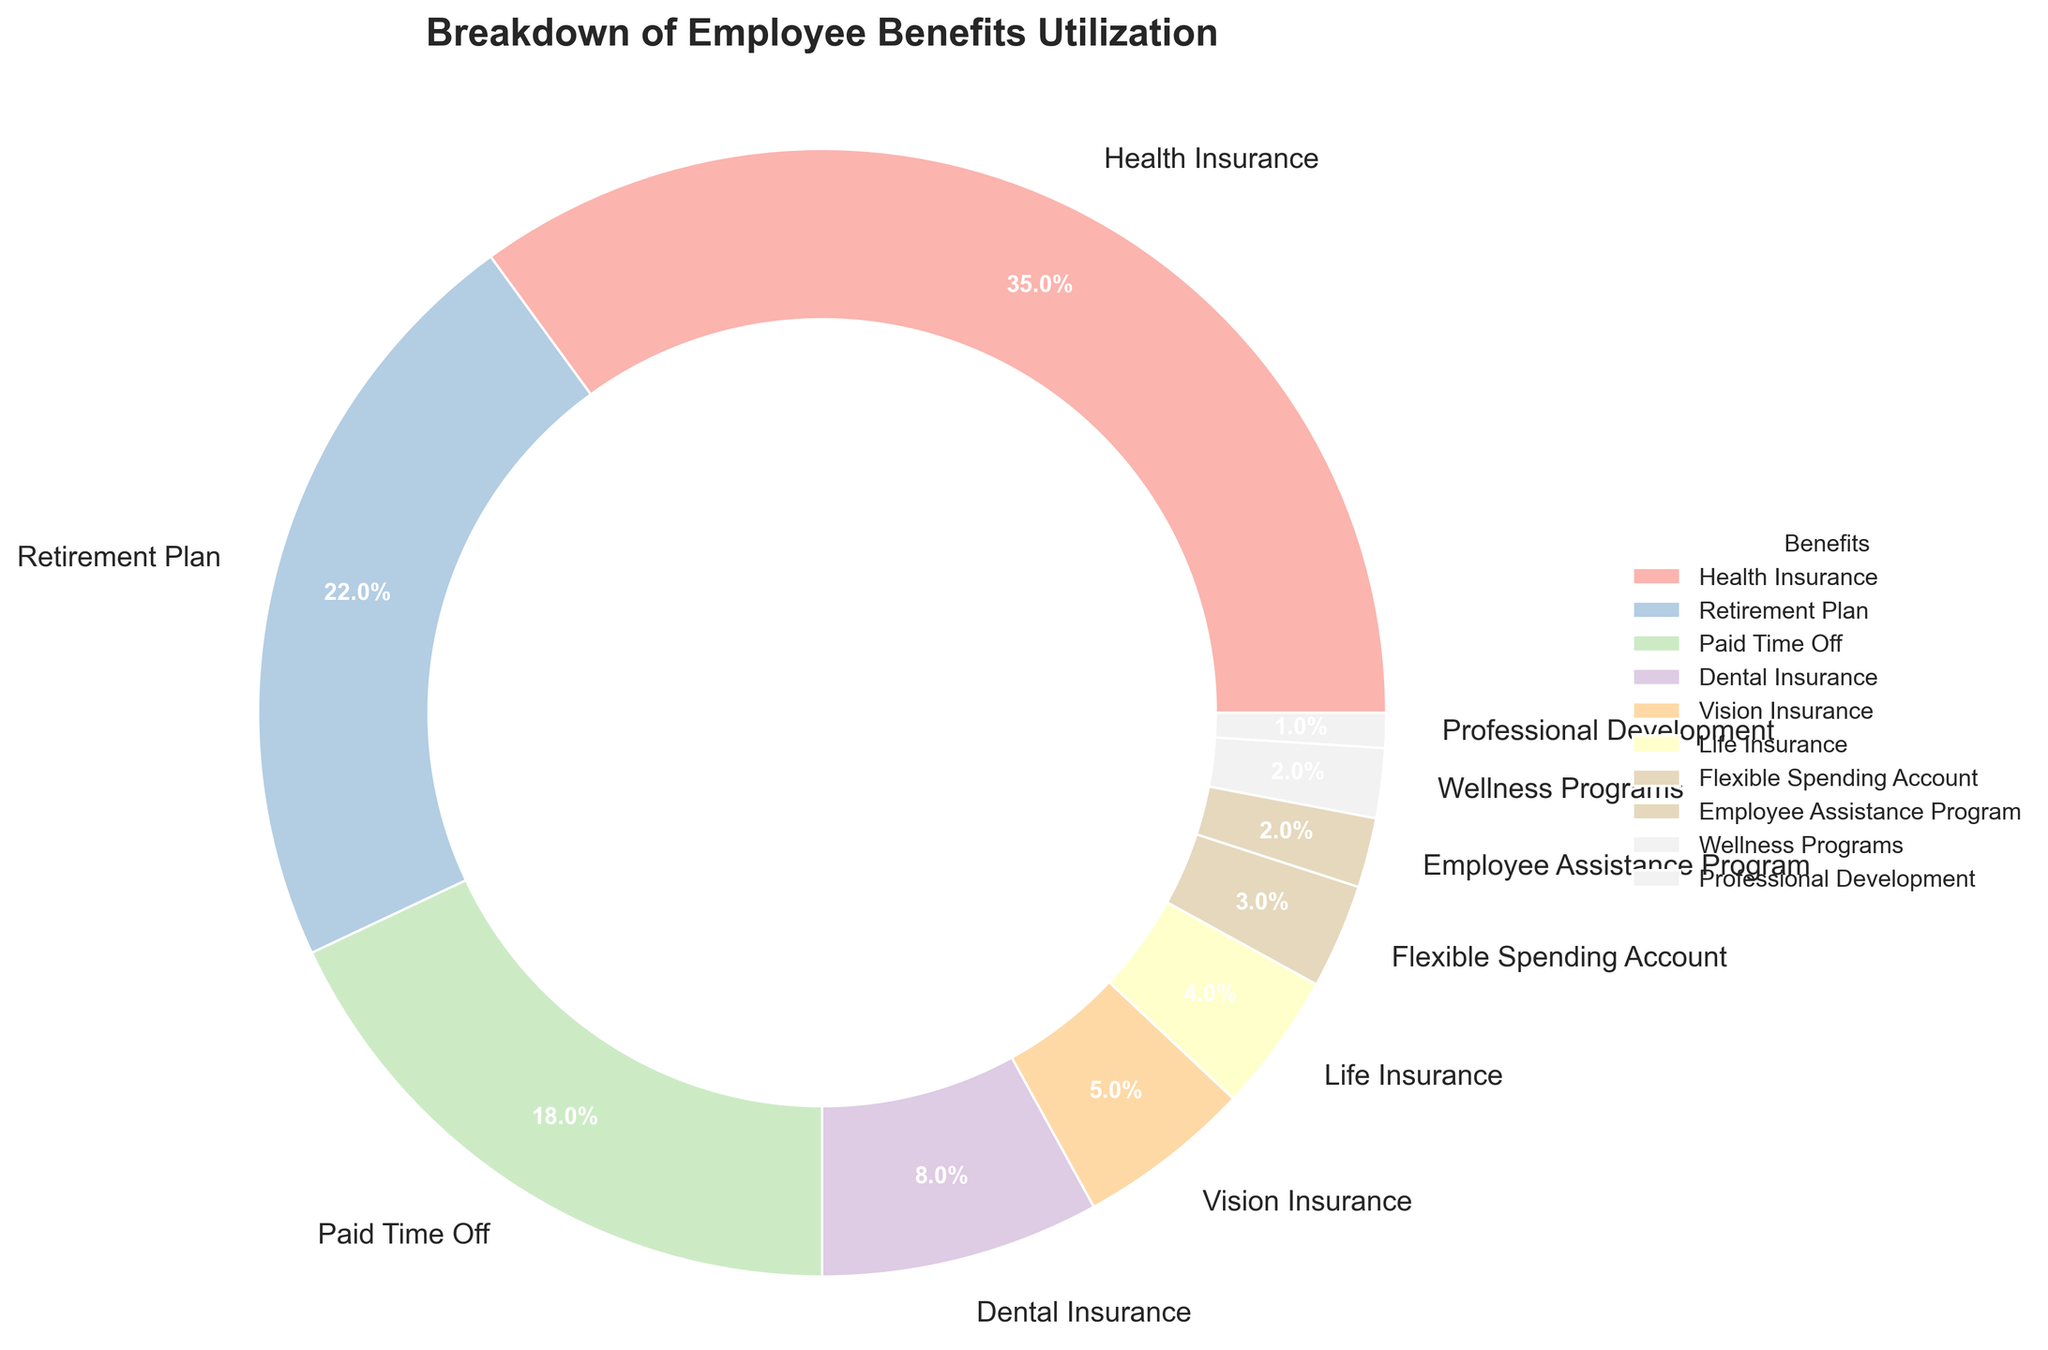Which benefit has the highest utilization percentage? Visually, the largest section of the pie chart is labeled "Health Insurance," showing it has the largest proportion.
Answer: Health Insurance What is the combined percentage of Health Insurance and Retirement Plan utilization? The percentages for Health Insurance and Retirement Plan are 35% and 22%, respectively. Summing them up gives 35% + 22% = 57%.
Answer: 57% How much more utilized is Health Insurance compared to Paid Time Off? The utilization percentage for Health Insurance is 35%, and for Paid Time Off, it is 18%. The difference is 35% - 18% = 17%.
Answer: 17% Which benefit has the lowest utilization percentage? The smallest segment in the pie chart is labeled "Professional Development," indicating it has the lowest proportion.
Answer: Professional Development Rank the top three benefits by utilization. By inspecting the size of the segments in the pie chart, we can see that the top three benefits by utilization are: 1) Health Insurance (35%), 2) Retirement Plan (22%), 3) Paid Time Off (18%).
Answer: Health Insurance, Retirement Plan, Paid Time Off Are Dental Insurance and Vision Insurance utilization percentages combined greater than that of Paid Time Off? The percentages for Dental Insurance and Vision Insurance are 8% and 5%, respectively. Combined, they are 8% + 5% = 13%. The percentage for Paid Time Off is 18%, which is greater.
Answer: No Is the utilization of Life Insurance more than twice the utilization of the Employee Assistance Program? The percentage for Life Insurance is 4%, and for the Employee Assistance Program, it is 2%. Since 4% is exactly twice 2%, Life Insurance is not more than twice as much.
Answer: No What is the difference in utilization percentages between Vision Insurance and the Flexible Spending Account? Vision Insurance has a utilization percentage of 5%, and the Flexible Spending Account has 3%. The difference is 5% - 3% = 2%.
Answer: 2% Is the total percentage of benefits with less than 5% utilization greater than or equal to 10%? Adding up the percentages for Vision Insurance (5%), Life Insurance (4%), Flexible Spending Account (3%), Employee Assistance Program (2%), Wellness Programs (2%), and Professional Development (1%) gives 5% + 4% + 3% + 2% + 2% + 1% = 17%, which is greater than 10%.
Answer: Yes What's the combined utilization percentage for benefits related to insurance (Health, Dental, Vision, Life)? Summing up the percentages for Health Insurance (35%), Dental Insurance (8%), Vision Insurance (5%), and Life Insurance (4%) gives 35% + 8% + 5% + 4% = 52%.
Answer: 52% 